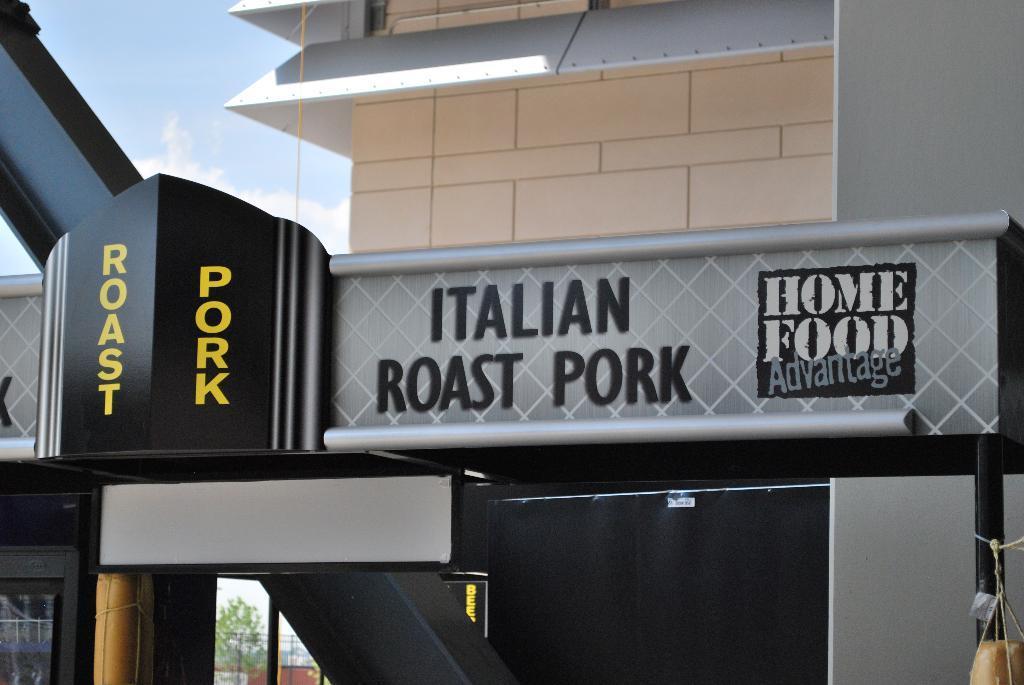Describe this image in one or two sentences. In the image there is a building with an arch in front of it, this seems to be restaurant, on the top its sky. 